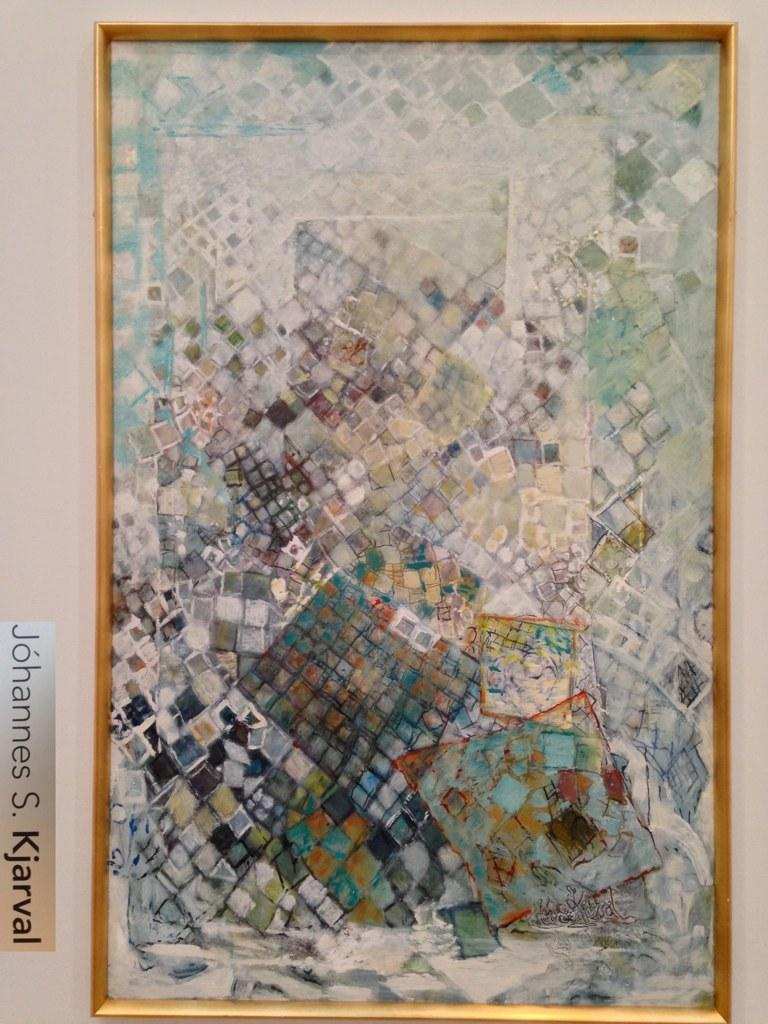<image>
Render a clear and concise summary of the photo. A colorful artwork that has been created by Johanes S. Kjarval. 